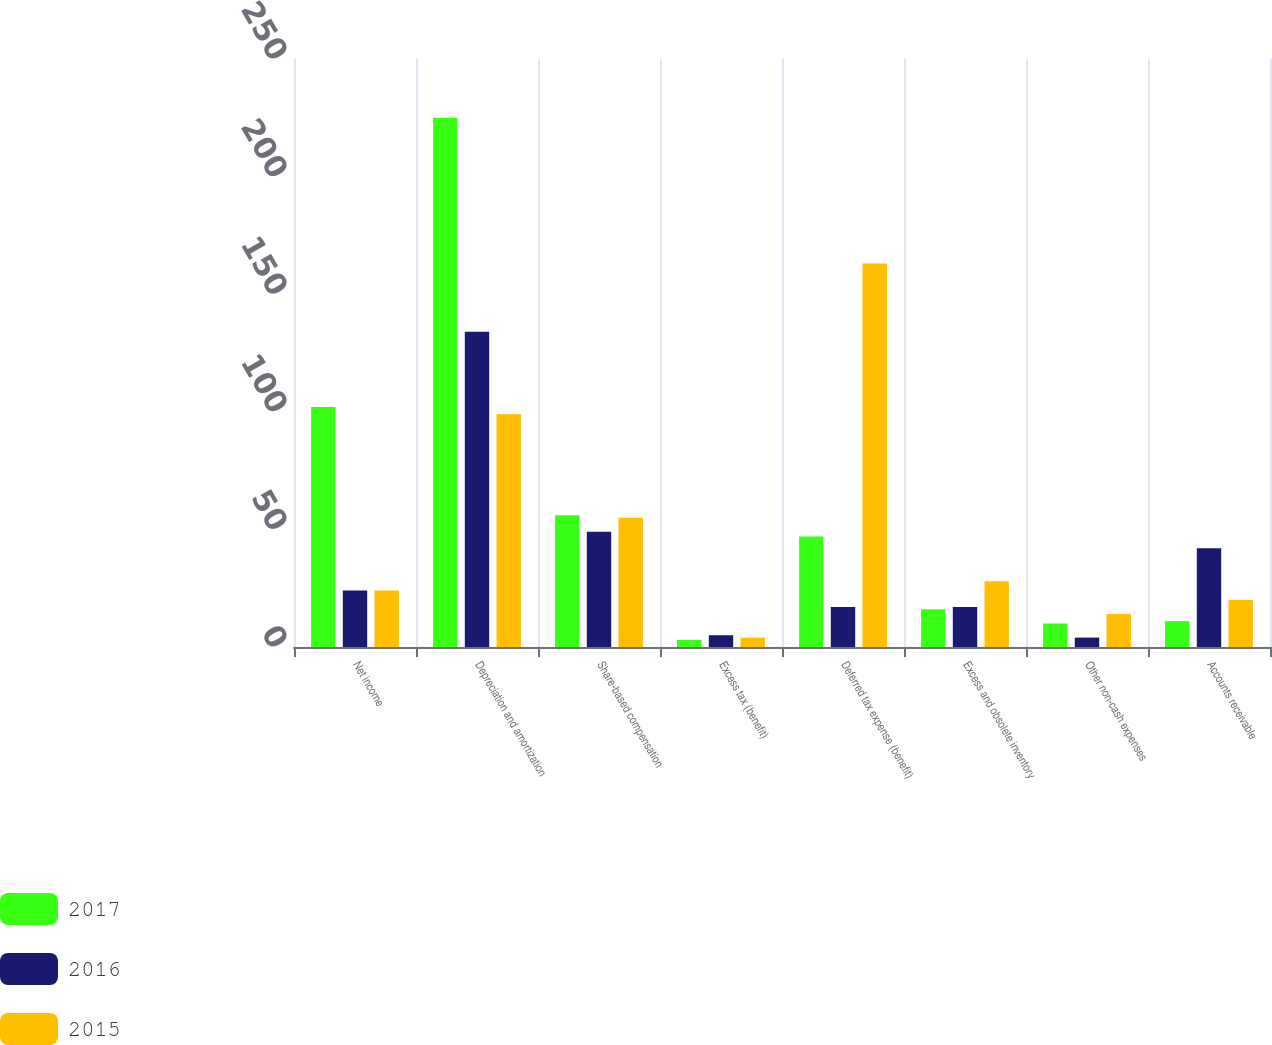Convert chart. <chart><loc_0><loc_0><loc_500><loc_500><stacked_bar_chart><ecel><fcel>Net income<fcel>Depreciation and amortization<fcel>Share-based compensation<fcel>Excess tax (benefit)<fcel>Deferred tax expense (benefit)<fcel>Excess and obsolete inventory<fcel>Other non-cash expenses<fcel>Accounts receivable<nl><fcel>2017<fcel>102<fcel>225<fcel>56<fcel>3<fcel>47<fcel>16<fcel>10<fcel>11<nl><fcel>2016<fcel>24<fcel>134<fcel>49<fcel>5<fcel>17<fcel>17<fcel>4<fcel>42<nl><fcel>2015<fcel>24<fcel>99<fcel>55<fcel>4<fcel>163<fcel>28<fcel>14<fcel>20<nl></chart> 